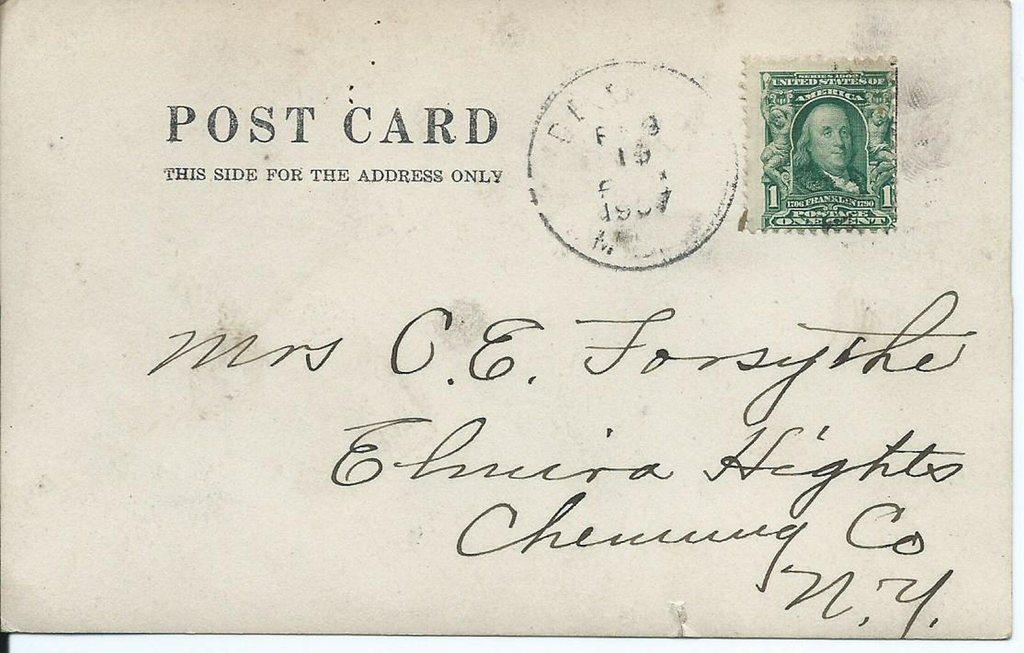<image>
Provide a brief description of the given image. a POST CARD Addressed to Mrs G E Forsyth of NY 